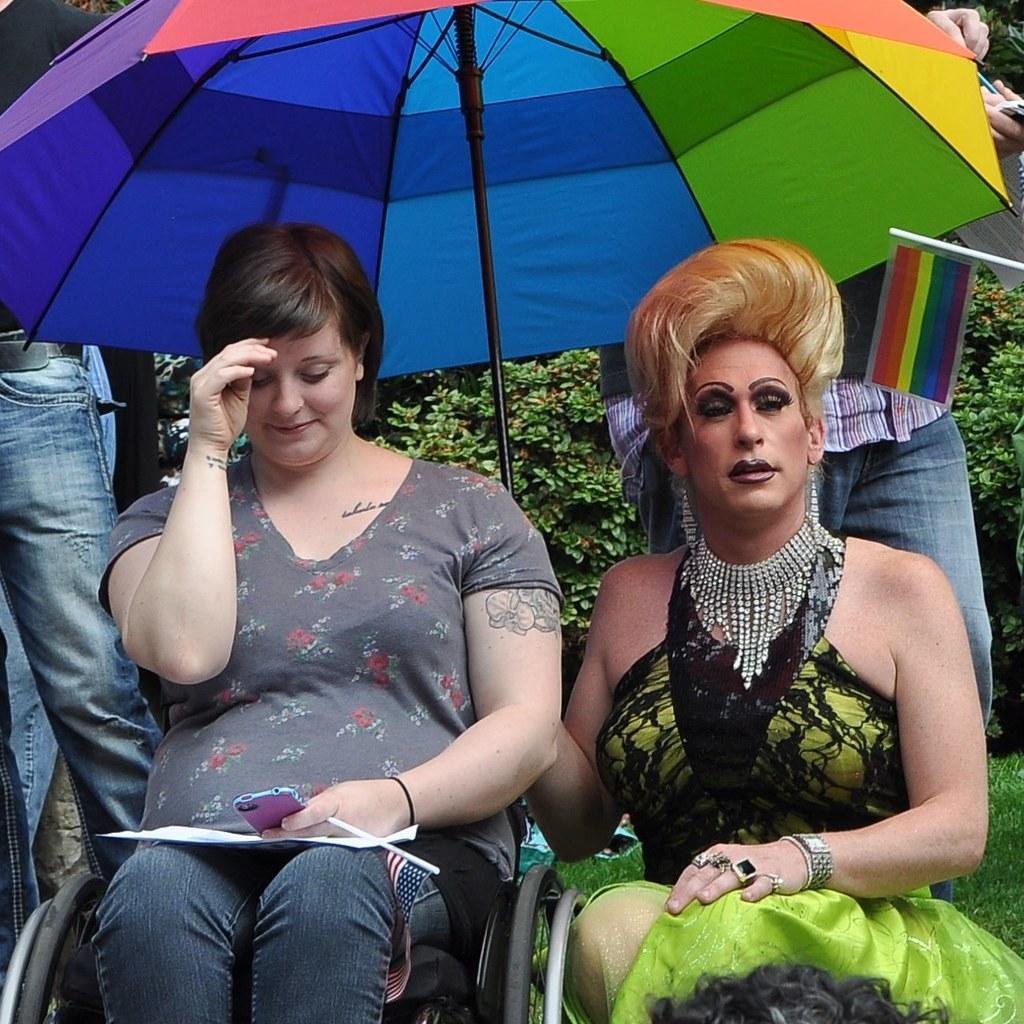How would you summarize this image in a sentence or two? In this image, we can see people wearing clothes. There is an umbrella at the top of the image. There is a person on the left side of the image sitting on a chair and holding a phone with her hand. There is a flag at the bottom of the image. In the background, we can see some plants. There is an another flag on the right side of the image. 